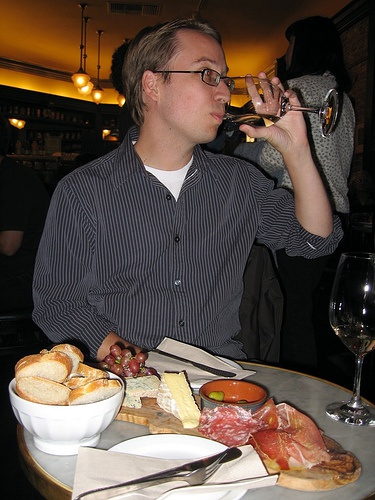Describe the objects in this image and their specific colors. I can see people in maroon, black, gray, brown, and tan tones, dining table in maroon, lightgray, gray, darkgray, and tan tones, people in maroon, black, and gray tones, bowl in maroon, white, tan, and darkgray tones, and wine glass in maroon, black, gray, and darkgray tones in this image. 